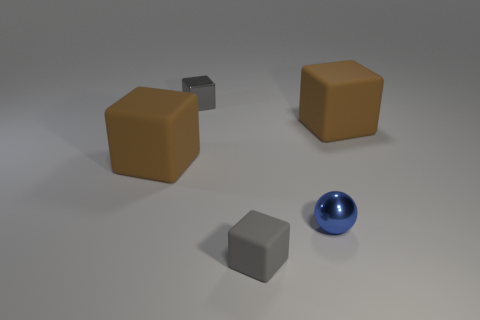Subtract all red blocks. Subtract all red cylinders. How many blocks are left? 4 Add 5 small blue shiny things. How many objects exist? 10 Subtract all blocks. How many objects are left? 1 Add 1 tiny gray rubber objects. How many tiny gray rubber objects are left? 2 Add 2 balls. How many balls exist? 3 Subtract 0 brown balls. How many objects are left? 5 Subtract all blue objects. Subtract all blue metallic spheres. How many objects are left? 3 